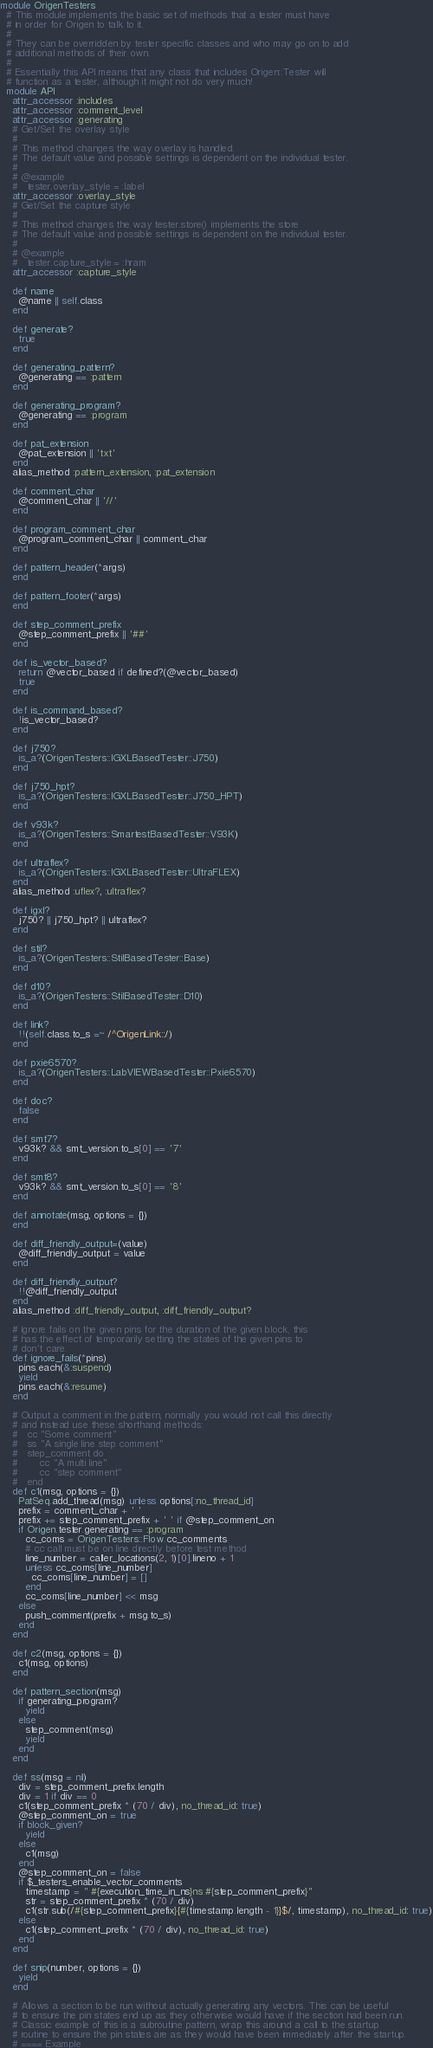<code> <loc_0><loc_0><loc_500><loc_500><_Ruby_>module OrigenTesters
  # This module implements the basic set of methods that a tester must have
  # in order for Origen to talk to it.
  #
  # They can be overridden by tester specific classes and who may go on to add
  # additional methods of their own.
  #
  # Essentially this API means that any class that includes Origen::Tester will
  # function as a tester, although it might not do very much!
  module API
    attr_accessor :includes
    attr_accessor :comment_level
    attr_accessor :generating
    # Get/Set the overlay style
    #
    # This method changes the way overlay is handled.
    # The default value and possible settings is dependent on the individual tester.
    #
    # @example
    #   tester.overlay_style = :label
    attr_accessor :overlay_style
    # Get/Set the capture style
    #
    # This method changes the way tester.store() implements the store
    # The default value and possible settings is dependent on the individual tester.
    #
    # @example
    #   tester.capture_style = :hram
    attr_accessor :capture_style

    def name
      @name || self.class
    end

    def generate?
      true
    end

    def generating_pattern?
      @generating == :pattern
    end

    def generating_program?
      @generating == :program
    end

    def pat_extension
      @pat_extension || 'txt'
    end
    alias_method :pattern_extension, :pat_extension

    def comment_char
      @comment_char || '//'
    end

    def program_comment_char
      @program_comment_char || comment_char
    end

    def pattern_header(*args)
    end

    def pattern_footer(*args)
    end

    def step_comment_prefix
      @step_comment_prefix || '##'
    end

    def is_vector_based?
      return @vector_based if defined?(@vector_based)
      true
    end

    def is_command_based?
      !is_vector_based?
    end

    def j750?
      is_a?(OrigenTesters::IGXLBasedTester::J750)
    end

    def j750_hpt?
      is_a?(OrigenTesters::IGXLBasedTester::J750_HPT)
    end

    def v93k?
      is_a?(OrigenTesters::SmartestBasedTester::V93K)
    end

    def ultraflex?
      is_a?(OrigenTesters::IGXLBasedTester::UltraFLEX)
    end
    alias_method :uflex?, :ultraflex?

    def igxl?
      j750? || j750_hpt? || ultraflex?
    end

    def stil?
      is_a?(OrigenTesters::StilBasedTester::Base)
    end

    def d10?
      is_a?(OrigenTesters::StilBasedTester::D10)
    end

    def link?
      !!(self.class.to_s =~ /^OrigenLink::/)
    end

    def pxie6570?
      is_a?(OrigenTesters::LabVIEWBasedTester::Pxie6570)
    end

    def doc?
      false
    end

    def smt7?
      v93k? && smt_version.to_s[0] == '7'
    end

    def smt8?
      v93k? && smt_version.to_s[0] == '8'
    end

    def annotate(msg, options = {})
    end

    def diff_friendly_output=(value)
      @diff_friendly_output = value
    end

    def diff_friendly_output?
      !!@diff_friendly_output
    end
    alias_method :diff_friendly_output, :diff_friendly_output?

    # Ignore fails on the given pins for the duration of the given block, this
    # has the effect of temporarily setting the states of the given pins to
    # don't care.
    def ignore_fails(*pins)
      pins.each(&:suspend)
      yield
      pins.each(&:resume)
    end

    # Output a comment in the pattern, normally you would not call this directly
    # and instead use these shorthand methods:
    #   cc "Some comment"
    #   ss "A single line step comment"
    #   step_comment do
    #       cc "A multi line"
    #       cc "step comment"
    #   end
    def c1(msg, options = {})
      PatSeq.add_thread(msg) unless options[:no_thread_id]
      prefix = comment_char + ' '
      prefix += step_comment_prefix + ' ' if @step_comment_on
      if Origen.tester.generating == :program
        cc_coms = OrigenTesters::Flow.cc_comments
        # cc call must be on line directly before test method
        line_number = caller_locations(2, 1)[0].lineno + 1
        unless cc_coms[line_number]
          cc_coms[line_number] = []
        end
        cc_coms[line_number] << msg
      else
        push_comment(prefix + msg.to_s)
      end
    end

    def c2(msg, options = {})
      c1(msg, options)
    end

    def pattern_section(msg)
      if generating_program?
        yield
      else
        step_comment(msg)
        yield
      end
    end

    def ss(msg = nil)
      div = step_comment_prefix.length
      div = 1 if div == 0
      c1(step_comment_prefix * (70 / div), no_thread_id: true)
      @step_comment_on = true
      if block_given?
        yield
      else
        c1(msg)
      end
      @step_comment_on = false
      if $_testers_enable_vector_comments
        timestamp = " #{execution_time_in_ns}ns #{step_comment_prefix}"
        str = step_comment_prefix * (70 / div)
        c1(str.sub(/#{step_comment_prefix}{#{timestamp.length - 1}}$/, timestamp), no_thread_id: true)
      else
        c1(step_comment_prefix * (70 / div), no_thread_id: true)
      end
    end

    def snip(number, options = {})
      yield
    end

    # Allows a section to be run without actually generating any vectors. This can be useful
    # to ensure the pin states end up as they otherwise would have if the section had been run.
    # Classic example of this is a subroutine pattern, wrap this around a call to the startup
    # routine to ensure the pin states are as they would have been immediately after the startup.
    # ==== Example</code> 